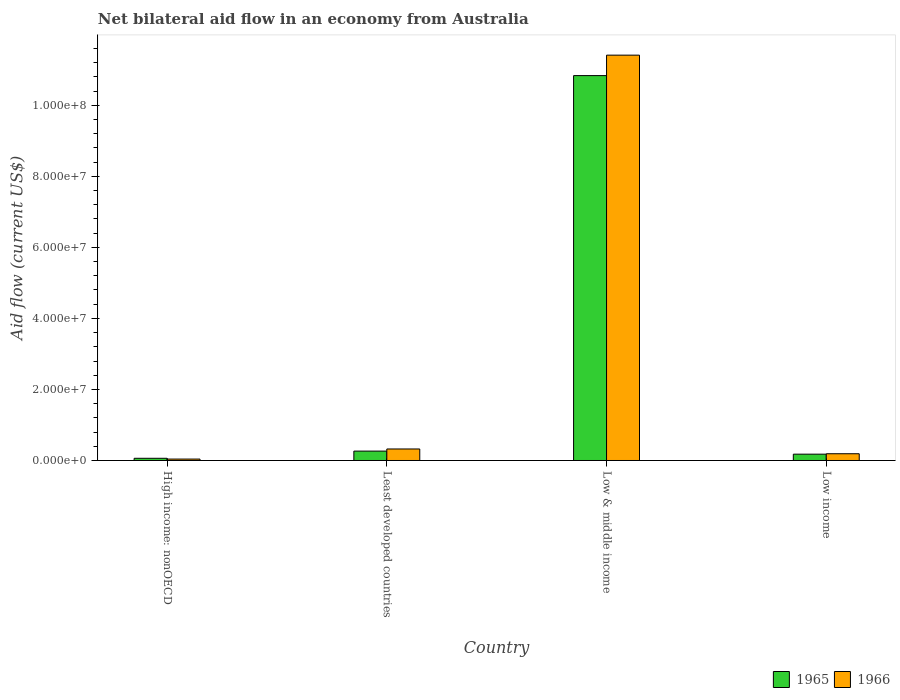How many groups of bars are there?
Keep it short and to the point. 4. In how many cases, is the number of bars for a given country not equal to the number of legend labels?
Provide a short and direct response. 0. What is the net bilateral aid flow in 1966 in Least developed countries?
Offer a very short reply. 3.24e+06. Across all countries, what is the maximum net bilateral aid flow in 1965?
Your answer should be very brief. 1.08e+08. Across all countries, what is the minimum net bilateral aid flow in 1965?
Offer a very short reply. 6.20e+05. In which country was the net bilateral aid flow in 1966 maximum?
Your answer should be compact. Low & middle income. In which country was the net bilateral aid flow in 1965 minimum?
Your answer should be compact. High income: nonOECD. What is the total net bilateral aid flow in 1966 in the graph?
Your answer should be compact. 1.20e+08. What is the difference between the net bilateral aid flow in 1965 in High income: nonOECD and that in Low & middle income?
Make the answer very short. -1.08e+08. What is the difference between the net bilateral aid flow in 1965 in Least developed countries and the net bilateral aid flow in 1966 in High income: nonOECD?
Provide a succinct answer. 2.24e+06. What is the average net bilateral aid flow in 1966 per country?
Ensure brevity in your answer.  2.99e+07. What is the difference between the net bilateral aid flow of/in 1965 and net bilateral aid flow of/in 1966 in Least developed countries?
Provide a short and direct response. -6.00e+05. In how many countries, is the net bilateral aid flow in 1966 greater than 32000000 US$?
Your answer should be very brief. 1. What is the ratio of the net bilateral aid flow in 1966 in High income: nonOECD to that in Least developed countries?
Provide a succinct answer. 0.12. Is the difference between the net bilateral aid flow in 1965 in High income: nonOECD and Low & middle income greater than the difference between the net bilateral aid flow in 1966 in High income: nonOECD and Low & middle income?
Your answer should be very brief. Yes. What is the difference between the highest and the second highest net bilateral aid flow in 1966?
Offer a very short reply. 1.12e+08. What is the difference between the highest and the lowest net bilateral aid flow in 1966?
Ensure brevity in your answer.  1.14e+08. In how many countries, is the net bilateral aid flow in 1966 greater than the average net bilateral aid flow in 1966 taken over all countries?
Offer a terse response. 1. Is the sum of the net bilateral aid flow in 1966 in Least developed countries and Low & middle income greater than the maximum net bilateral aid flow in 1965 across all countries?
Your answer should be compact. Yes. What does the 1st bar from the left in Low income represents?
Make the answer very short. 1965. What does the 1st bar from the right in Low income represents?
Your answer should be compact. 1966. How many bars are there?
Offer a very short reply. 8. Are all the bars in the graph horizontal?
Your answer should be very brief. No. How many countries are there in the graph?
Keep it short and to the point. 4. Where does the legend appear in the graph?
Your answer should be compact. Bottom right. How are the legend labels stacked?
Make the answer very short. Horizontal. What is the title of the graph?
Offer a very short reply. Net bilateral aid flow in an economy from Australia. Does "1998" appear as one of the legend labels in the graph?
Keep it short and to the point. No. What is the label or title of the X-axis?
Ensure brevity in your answer.  Country. What is the label or title of the Y-axis?
Your response must be concise. Aid flow (current US$). What is the Aid flow (current US$) of 1965 in High income: nonOECD?
Your answer should be compact. 6.20e+05. What is the Aid flow (current US$) of 1966 in High income: nonOECD?
Provide a succinct answer. 4.00e+05. What is the Aid flow (current US$) of 1965 in Least developed countries?
Your response must be concise. 2.64e+06. What is the Aid flow (current US$) of 1966 in Least developed countries?
Provide a succinct answer. 3.24e+06. What is the Aid flow (current US$) of 1965 in Low & middle income?
Your answer should be compact. 1.08e+08. What is the Aid flow (current US$) of 1966 in Low & middle income?
Your response must be concise. 1.14e+08. What is the Aid flow (current US$) of 1965 in Low income?
Your response must be concise. 1.78e+06. What is the Aid flow (current US$) in 1966 in Low income?
Keep it short and to the point. 1.90e+06. Across all countries, what is the maximum Aid flow (current US$) of 1965?
Offer a terse response. 1.08e+08. Across all countries, what is the maximum Aid flow (current US$) in 1966?
Provide a short and direct response. 1.14e+08. Across all countries, what is the minimum Aid flow (current US$) in 1965?
Provide a succinct answer. 6.20e+05. Across all countries, what is the minimum Aid flow (current US$) of 1966?
Your answer should be compact. 4.00e+05. What is the total Aid flow (current US$) in 1965 in the graph?
Your answer should be compact. 1.13e+08. What is the total Aid flow (current US$) of 1966 in the graph?
Your answer should be compact. 1.20e+08. What is the difference between the Aid flow (current US$) of 1965 in High income: nonOECD and that in Least developed countries?
Your response must be concise. -2.02e+06. What is the difference between the Aid flow (current US$) of 1966 in High income: nonOECD and that in Least developed countries?
Make the answer very short. -2.84e+06. What is the difference between the Aid flow (current US$) in 1965 in High income: nonOECD and that in Low & middle income?
Ensure brevity in your answer.  -1.08e+08. What is the difference between the Aid flow (current US$) of 1966 in High income: nonOECD and that in Low & middle income?
Give a very brief answer. -1.14e+08. What is the difference between the Aid flow (current US$) in 1965 in High income: nonOECD and that in Low income?
Your answer should be very brief. -1.16e+06. What is the difference between the Aid flow (current US$) of 1966 in High income: nonOECD and that in Low income?
Provide a succinct answer. -1.50e+06. What is the difference between the Aid flow (current US$) in 1965 in Least developed countries and that in Low & middle income?
Give a very brief answer. -1.06e+08. What is the difference between the Aid flow (current US$) of 1966 in Least developed countries and that in Low & middle income?
Your response must be concise. -1.11e+08. What is the difference between the Aid flow (current US$) in 1965 in Least developed countries and that in Low income?
Your answer should be very brief. 8.60e+05. What is the difference between the Aid flow (current US$) of 1966 in Least developed countries and that in Low income?
Offer a very short reply. 1.34e+06. What is the difference between the Aid flow (current US$) in 1965 in Low & middle income and that in Low income?
Offer a very short reply. 1.07e+08. What is the difference between the Aid flow (current US$) of 1966 in Low & middle income and that in Low income?
Provide a succinct answer. 1.12e+08. What is the difference between the Aid flow (current US$) of 1965 in High income: nonOECD and the Aid flow (current US$) of 1966 in Least developed countries?
Your response must be concise. -2.62e+06. What is the difference between the Aid flow (current US$) in 1965 in High income: nonOECD and the Aid flow (current US$) in 1966 in Low & middle income?
Provide a succinct answer. -1.14e+08. What is the difference between the Aid flow (current US$) in 1965 in High income: nonOECD and the Aid flow (current US$) in 1966 in Low income?
Provide a short and direct response. -1.28e+06. What is the difference between the Aid flow (current US$) of 1965 in Least developed countries and the Aid flow (current US$) of 1966 in Low & middle income?
Your response must be concise. -1.11e+08. What is the difference between the Aid flow (current US$) in 1965 in Least developed countries and the Aid flow (current US$) in 1966 in Low income?
Provide a succinct answer. 7.40e+05. What is the difference between the Aid flow (current US$) in 1965 in Low & middle income and the Aid flow (current US$) in 1966 in Low income?
Offer a terse response. 1.06e+08. What is the average Aid flow (current US$) of 1965 per country?
Ensure brevity in your answer.  2.84e+07. What is the average Aid flow (current US$) in 1966 per country?
Offer a terse response. 2.99e+07. What is the difference between the Aid flow (current US$) in 1965 and Aid flow (current US$) in 1966 in Least developed countries?
Offer a terse response. -6.00e+05. What is the difference between the Aid flow (current US$) of 1965 and Aid flow (current US$) of 1966 in Low & middle income?
Offer a terse response. -5.76e+06. What is the ratio of the Aid flow (current US$) in 1965 in High income: nonOECD to that in Least developed countries?
Make the answer very short. 0.23. What is the ratio of the Aid flow (current US$) of 1966 in High income: nonOECD to that in Least developed countries?
Make the answer very short. 0.12. What is the ratio of the Aid flow (current US$) of 1965 in High income: nonOECD to that in Low & middle income?
Provide a succinct answer. 0.01. What is the ratio of the Aid flow (current US$) of 1966 in High income: nonOECD to that in Low & middle income?
Give a very brief answer. 0. What is the ratio of the Aid flow (current US$) of 1965 in High income: nonOECD to that in Low income?
Your answer should be very brief. 0.35. What is the ratio of the Aid flow (current US$) in 1966 in High income: nonOECD to that in Low income?
Offer a very short reply. 0.21. What is the ratio of the Aid flow (current US$) in 1965 in Least developed countries to that in Low & middle income?
Ensure brevity in your answer.  0.02. What is the ratio of the Aid flow (current US$) of 1966 in Least developed countries to that in Low & middle income?
Ensure brevity in your answer.  0.03. What is the ratio of the Aid flow (current US$) in 1965 in Least developed countries to that in Low income?
Ensure brevity in your answer.  1.48. What is the ratio of the Aid flow (current US$) of 1966 in Least developed countries to that in Low income?
Give a very brief answer. 1.71. What is the ratio of the Aid flow (current US$) in 1965 in Low & middle income to that in Low income?
Provide a succinct answer. 60.88. What is the ratio of the Aid flow (current US$) in 1966 in Low & middle income to that in Low income?
Your answer should be compact. 60.06. What is the difference between the highest and the second highest Aid flow (current US$) of 1965?
Your answer should be compact. 1.06e+08. What is the difference between the highest and the second highest Aid flow (current US$) of 1966?
Your response must be concise. 1.11e+08. What is the difference between the highest and the lowest Aid flow (current US$) in 1965?
Offer a very short reply. 1.08e+08. What is the difference between the highest and the lowest Aid flow (current US$) of 1966?
Your response must be concise. 1.14e+08. 